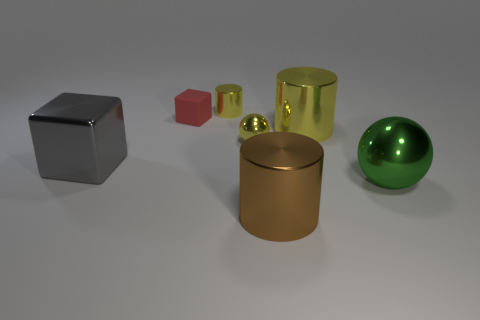Are there any other things that are the same material as the small red thing?
Offer a very short reply. No. What number of things are metallic spheres or yellow metal cylinders behind the tiny red object?
Your answer should be compact. 3. Is the number of cylinders in front of the small red rubber block greater than the number of red matte things?
Ensure brevity in your answer.  Yes. Are there an equal number of tiny red cubes that are right of the small yellow metal cylinder and tiny yellow spheres that are behind the big brown shiny thing?
Make the answer very short. No. Is there a large thing to the left of the object that is behind the rubber block?
Keep it short and to the point. Yes. There is a tiny red object; what shape is it?
Ensure brevity in your answer.  Cube. What size is the other metal cylinder that is the same color as the tiny cylinder?
Offer a terse response. Large. What size is the shiny sphere that is behind the cube on the left side of the tiny red matte object?
Your response must be concise. Small. There is a metallic ball behind the large green metal ball; how big is it?
Provide a succinct answer. Small. Is the number of cubes that are in front of the red rubber thing less than the number of big things that are on the left side of the large yellow cylinder?
Keep it short and to the point. Yes. 